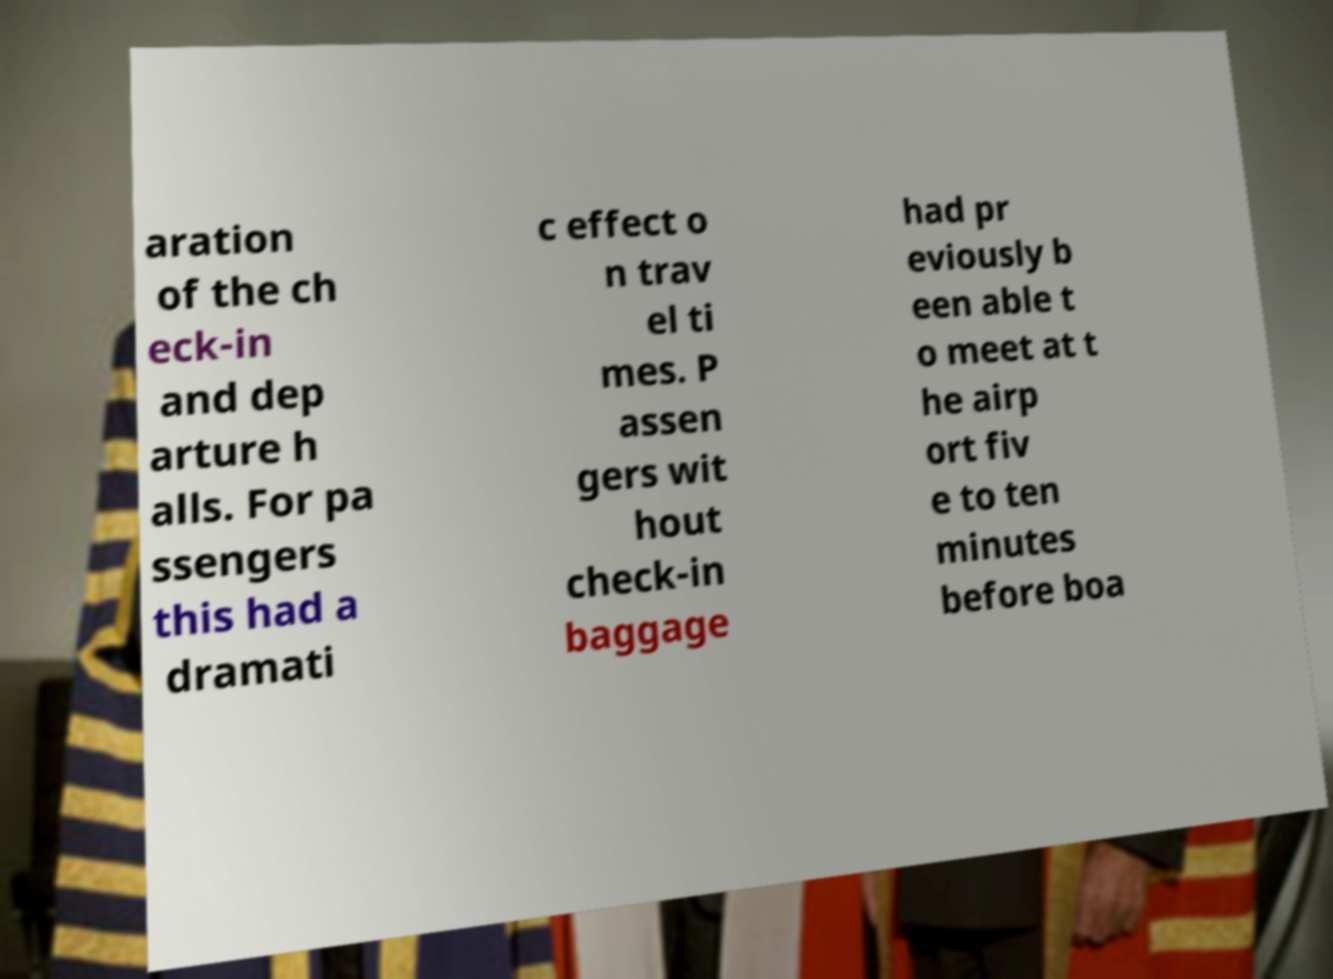Could you extract and type out the text from this image? aration of the ch eck-in and dep arture h alls. For pa ssengers this had a dramati c effect o n trav el ti mes. P assen gers wit hout check-in baggage had pr eviously b een able t o meet at t he airp ort fiv e to ten minutes before boa 